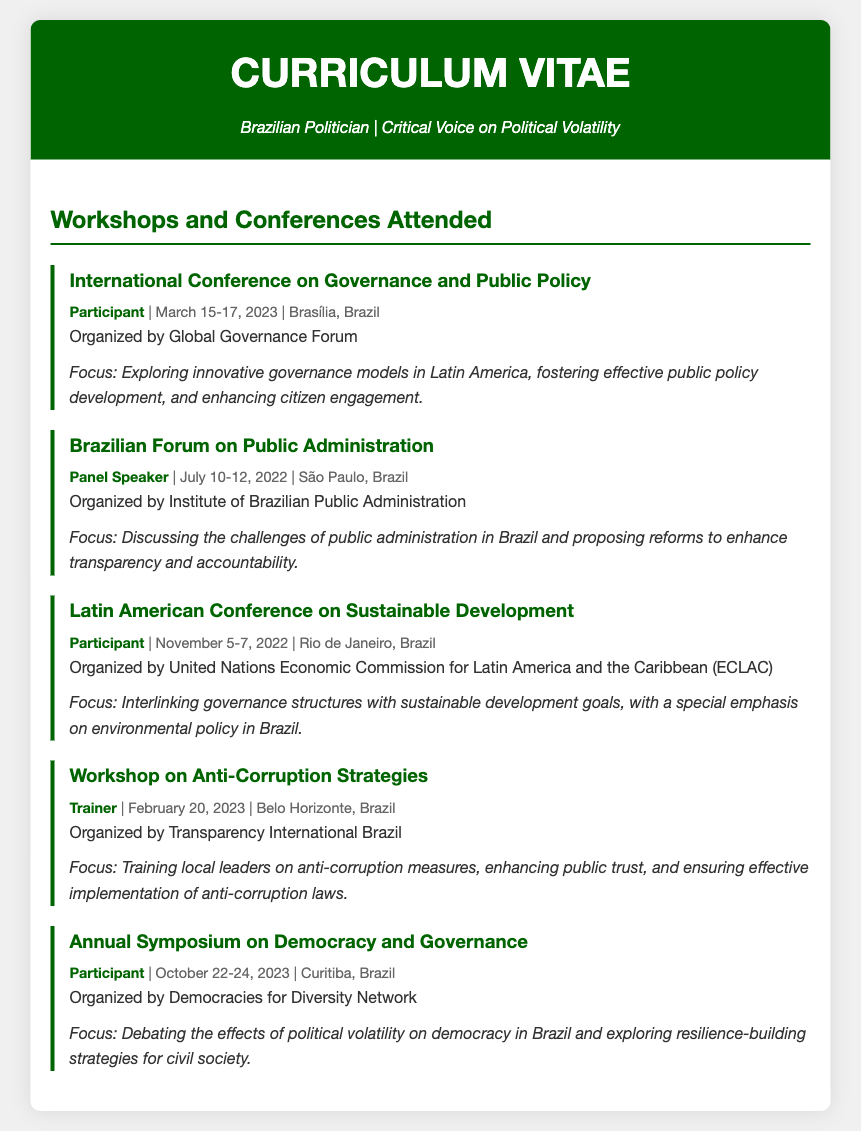what is the title of the first conference attended? The title of the first conference is listed as "International Conference on Governance and Public Policy."
Answer: International Conference on Governance and Public Policy who organized the Workshop on Anti-Corruption Strategies? The organization responsible for the Workshop on Anti-Corruption Strategies is Transparency International Brazil.
Answer: Transparency International Brazil when did the Annual Symposium on Democracy and Governance take place? The Annual Symposium on Democracy and Governance occurred from October 22-24, 2023.
Answer: October 22-24, 2023 what was the focus of the Brazilian Forum on Public Administration? The focus of the Brazilian Forum on Public Administration included discussing challenges of public administration in Brazil and proposing reforms to enhance transparency and accountability.
Answer: Challenges of public administration and proposing reforms how many workshops and conferences are listed in the document? The document lists a total of five workshops and conferences attended.
Answer: Five what role did the individual have at the Brazilian Forum on Public Administration? At the Brazilian Forum on Public Administration, the individual served as a Panel Speaker.
Answer: Panel Speaker which city hosted the Latin American Conference on Sustainable Development? The Latin American Conference on Sustainable Development was hosted in Rio de Janeiro, Brazil.
Answer: Rio de Janeiro what is the main theme of the Annual Symposium on Democracy and Governance? The main theme of the Annual Symposium on Democracy and Governance is debating the effects of political volatility on democracy in Brazil.
Answer: Effects of political volatility on democracy 